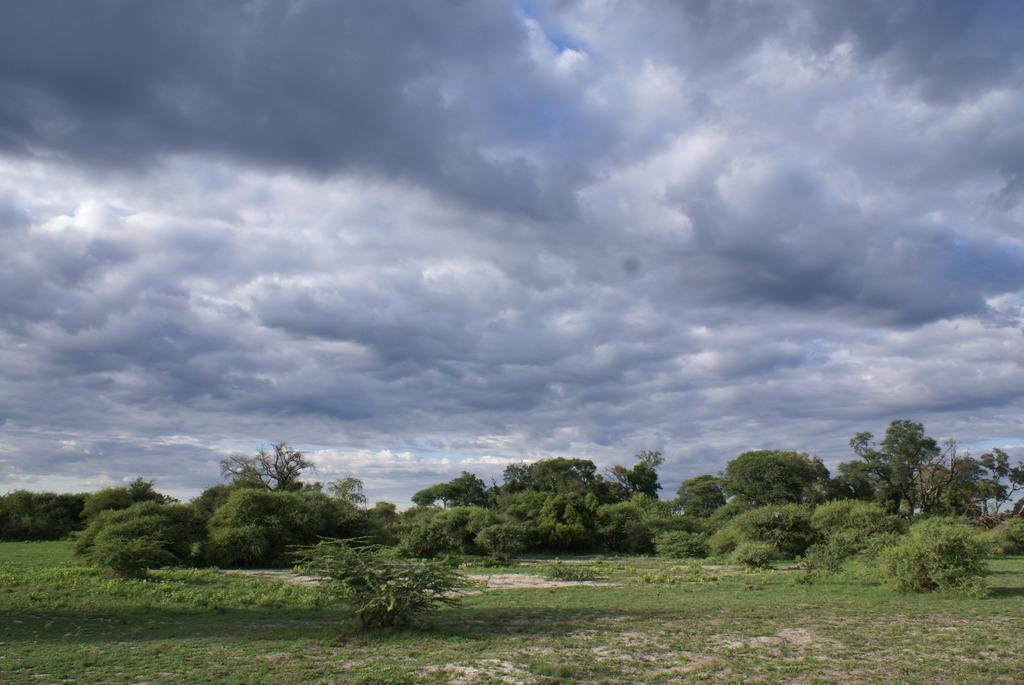What type of vegetation is present in the image? There is grass in the image. What other natural elements can be seen in the image? There are trees in the image. What part of the natural environment is visible in the image? The sky is visible in the image. What can be observed in the sky in the image? There are clouds in the sky. What type of sand can be seen being rubbed on the trees in the image? There is no sand or rubbing action present in the image; it features grass, trees, the sky, and clouds. 